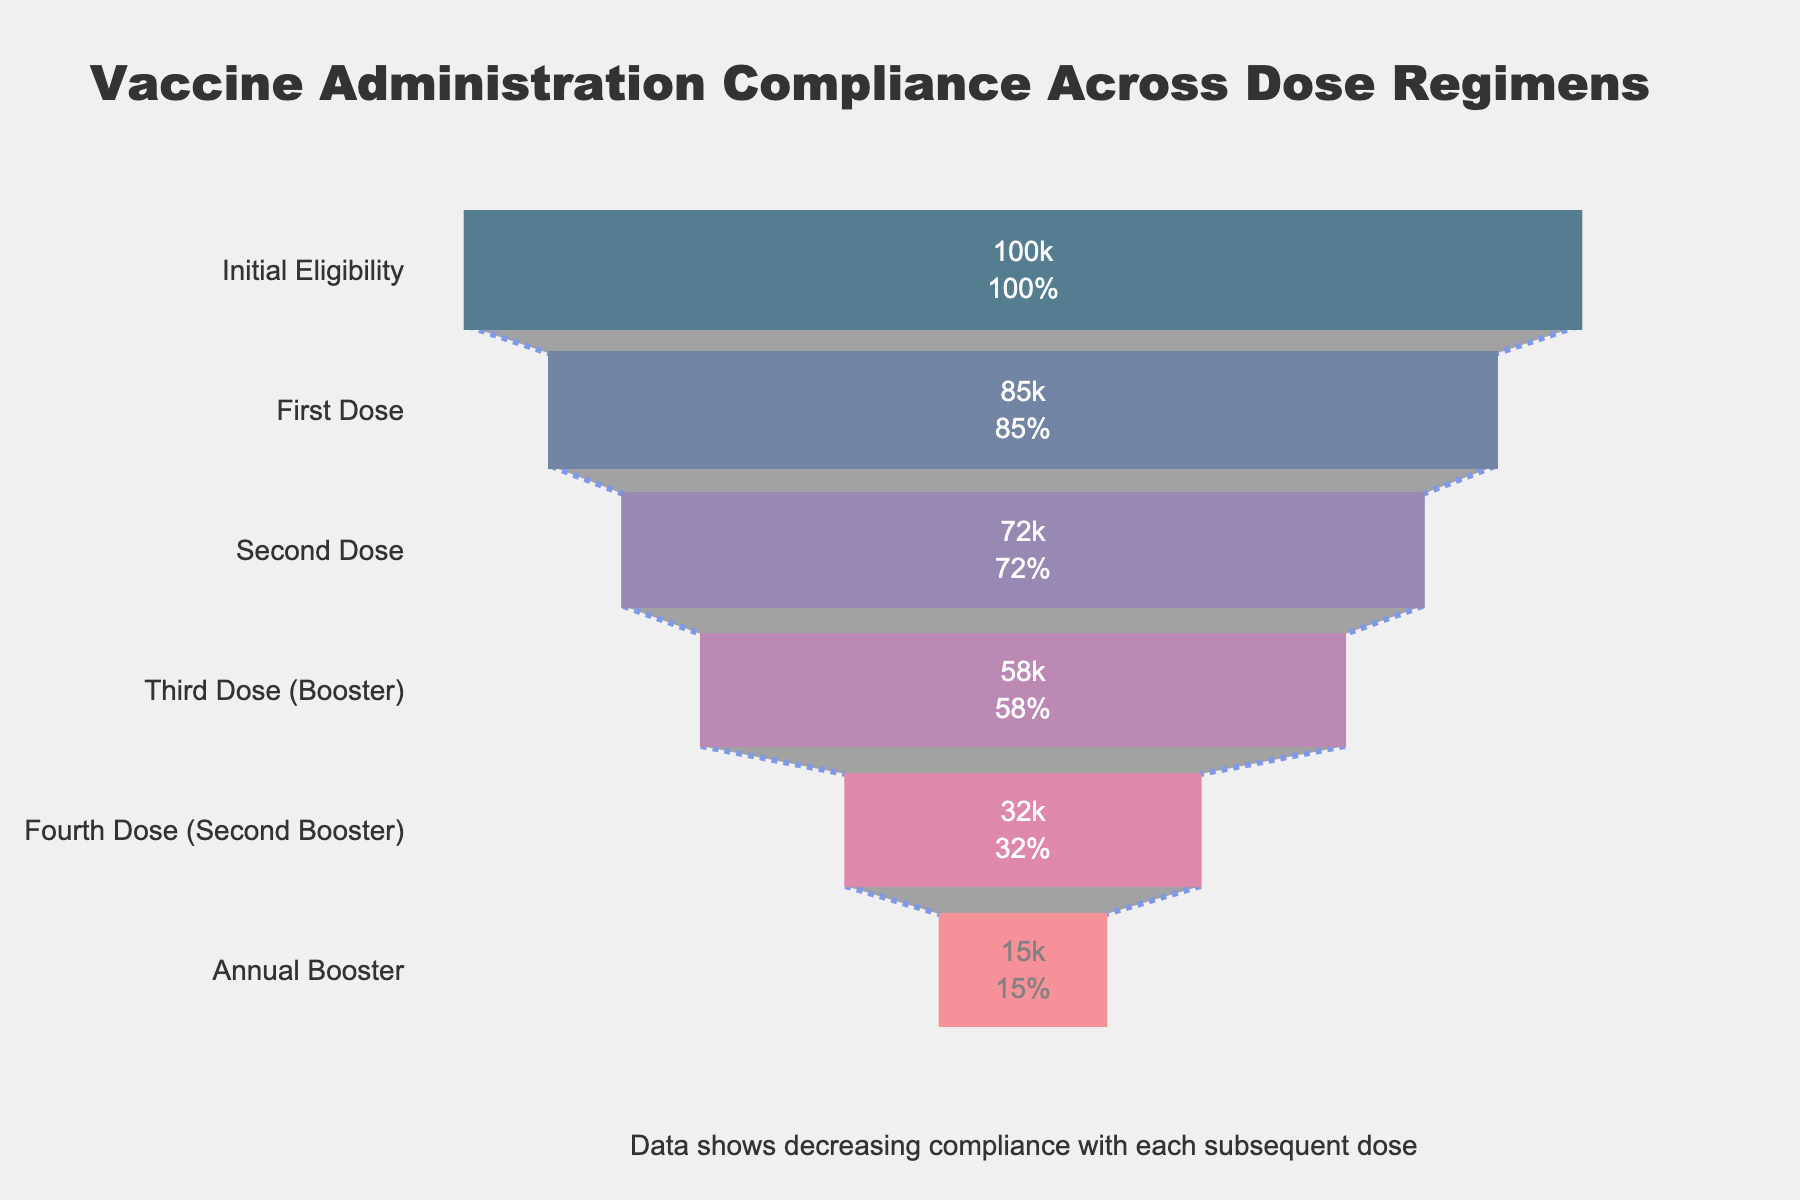What is the title of the graph? The title is generally located at the top of the figure, within the layout of the visual elements. By directly observing this part of the chart, we can see the title text presented there.
Answer: Vaccine Administration Compliance Across Dose Regimens How many patients were eligible initially? The initial number of eligible patients is labeled at the top of the funnel chart under the stage "Initial Eligibility," shown with its count.
Answer: 100000 By how much did the number of patients drop between the first dose and the second dose? Subtract the number of patients at the "Second Dose" stage from the number of patients at the "First Dose" stage to find the difference. Calculation: 85000 - 72000.
Answer: 13000 What percentage of patients who were initially eligible took the annual booster? To find the percentage of patients who took the annual booster relative to the initial eligibility, divide the number of annual booster patients by the initial eligible patients and multiply by 100. Calculation: (15000 / 100000) * 100.
Answer: 15% Between which two stages is the greatest drop in patient numbers observed? Examine the difference in patient numbers between each adjacent pair of stages and identify the largest decrease. Comparing (Initial Eligibility to First Dose: 15000), (First Dose to Second Dose: 13000), (Second Dose to Third Dose: 14000), (Third Dose to Fourth Dose: 26000), (Fourth Dose to Annual Booster: 17000) shows the largest drop is between Third Dose to Fourth Dose.
Answer: Third Dose (Booster) to Fourth Dose (Second Booster) How many steps are present in the funnel chart? Each stage in the funnel chart corresponds to a step, which can be counted directly from top to bottom. The steps are "Initial Eligibility," "First Dose," "Second Dose," "Third Dose (Booster)," "Fourth Dose (Second Booster)," and "Annual Booster."
Answer: 6 What color represents the "Third Dose (Booster)" stage in the chart? Notice the color associated with the "Third Dose (Booster)" label in the funnel chart. Each stage has a distinct hue that can be visually inspected.
Answer: Purple What can be inferred from the annotation at the bottom of the chart? The annotation provides a summary of the overall trend or key insight from the data, which in this case emphasizes the decreasing trend in compliance with each subsequent dose. Interpretation of the annotation tells us this is happening consistently at each stage.
Answer: Decreasing compliance with each subsequent dose 